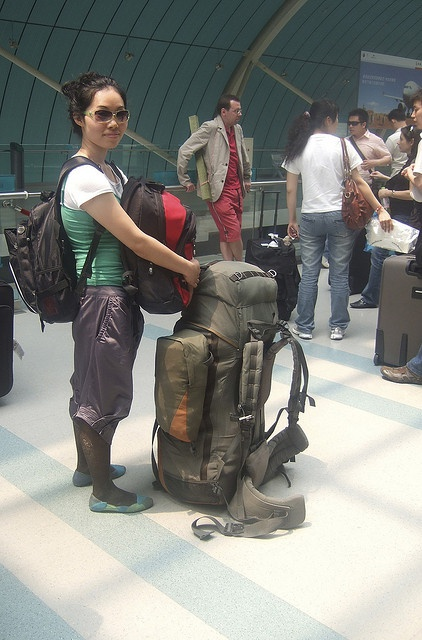Describe the objects in this image and their specific colors. I can see people in black, gray, and white tones, backpack in black and gray tones, people in black, gray, lightgray, and darkgray tones, backpack in black, gray, and darkgray tones, and backpack in black, gray, maroon, and salmon tones in this image. 